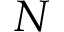<formula> <loc_0><loc_0><loc_500><loc_500>N</formula> 